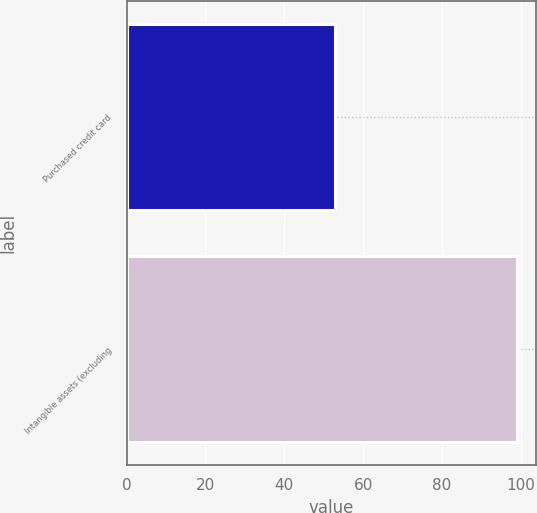<chart> <loc_0><loc_0><loc_500><loc_500><bar_chart><fcel>Purchased credit card<fcel>Intangible assets (excluding<nl><fcel>53<fcel>99<nl></chart> 